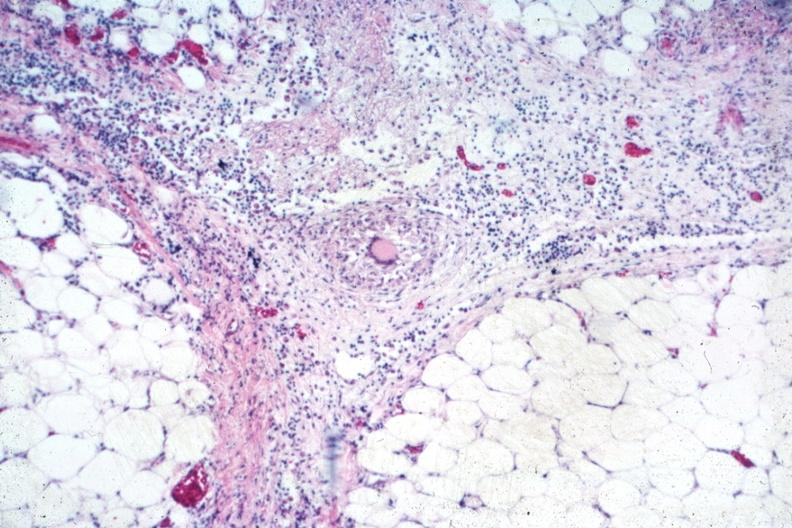s opened muscle present?
Answer the question using a single word or phrase. No 